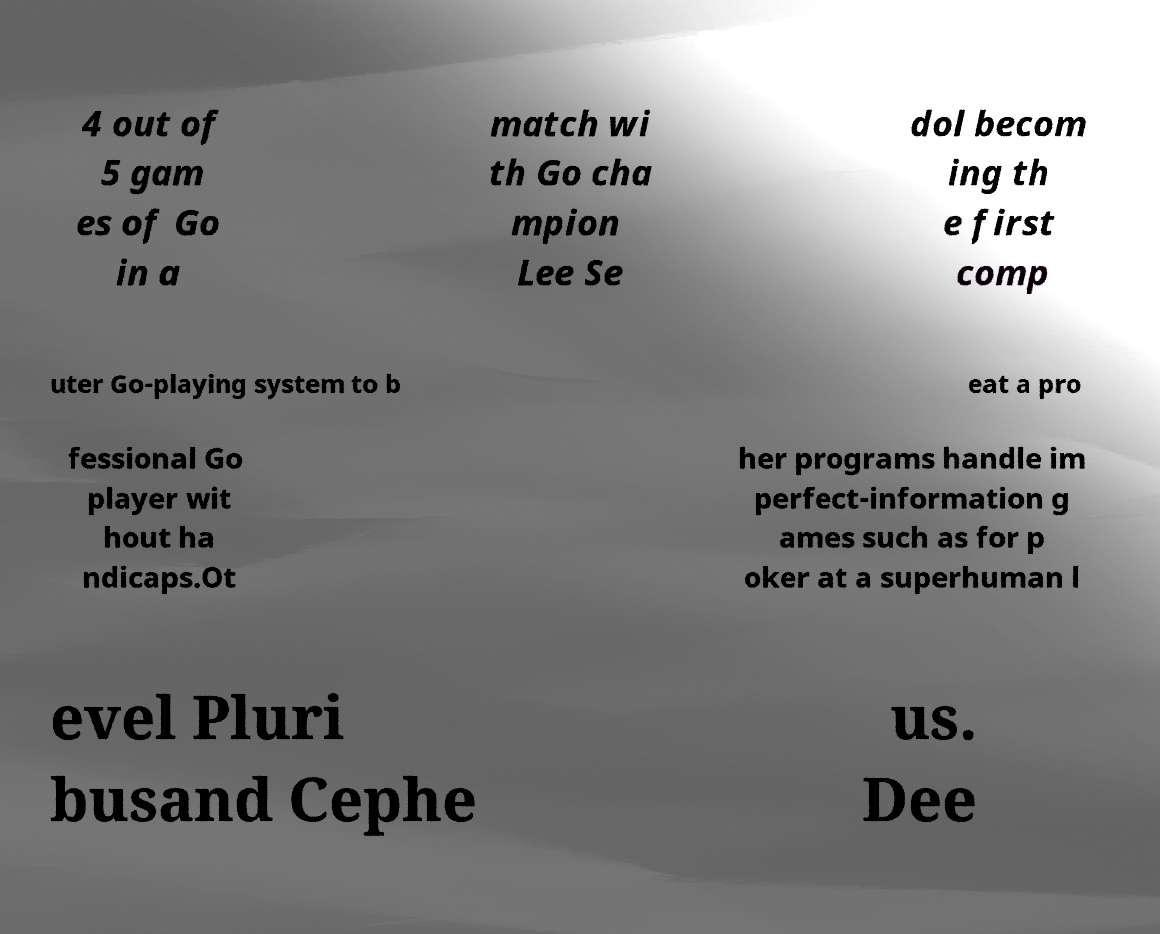Please identify and transcribe the text found in this image. 4 out of 5 gam es of Go in a match wi th Go cha mpion Lee Se dol becom ing th e first comp uter Go-playing system to b eat a pro fessional Go player wit hout ha ndicaps.Ot her programs handle im perfect-information g ames such as for p oker at a superhuman l evel Pluri busand Cephe us. Dee 